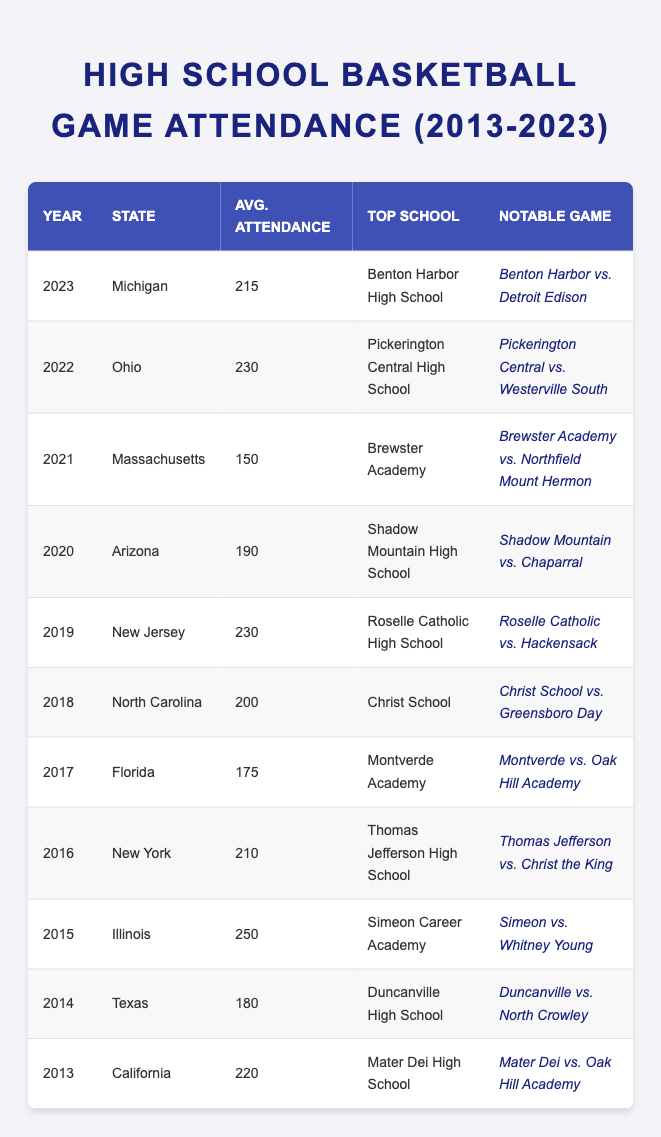What was the average attendance for high school basketball games in 2020? According to the table, the average attendance in 2020 was listed under Arizona, which shows 190.
Answer: 190 Which state had the highest average attendance in 2015? In the table, the year 2015 shows Illinois with an average attendance of 250, which is the highest among all years listed.
Answer: Illinois Was Brewster Academy the top school in Massachusetts for average attendance? The table lists Brewster Academy as the top school for Massachusetts in 2021 with an average attendance of 150, confirming it is indeed the top school for that state and year.
Answer: Yes What year had the lowest average attendance? Looking through the attendance figures, the year with the lowest average attendance is 2021 in Massachusetts with 150, which is less than all other years.
Answer: 2021 Which two states had an average attendance of 230? By reviewing the table, in 2019 New Jersey and in 2022 Ohio both have an average attendance of 230, indicating these two states share the same attendance figure for their respective years.
Answer: New Jersey and Ohio What is the difference in average attendance between 2015 and 2016? The average attendance in 2015 was 250 and in 2016 was 210. The difference is calculated as 250 - 210, resulting in 40.
Answer: 40 For which school was the notable game between "Montverde vs. Oak Hill Academy"? The notable game "Montverde vs. Oak Hill Academy" is listed in the year 2017 under the state Florida, indicating that Montverde Academy was the top school that year.
Answer: Montverde Academy What was the average attendance in California in 2013? The table shows that in 2013, California had an average attendance of 220 for high school basketball games, specifically at Mater Dei High School.
Answer: 220 How does the 2021 average attendance compare to the average attendance in 2013? In 2021, the average attendance was 150 and in 2013, it was 220. To find the difference, subtract 150 from 220, which equals 70, indicating that 2021 had significantly lower attendance compared to 2013.
Answer: 70 Which year had a notable game featuring "Roselle Catholic vs. Hackensack"? The notable game "Roselle Catholic vs. Hackensack" is listed for the year 2019 in the state of New Jersey, making this the relevant year for that matchup.
Answer: 2019 